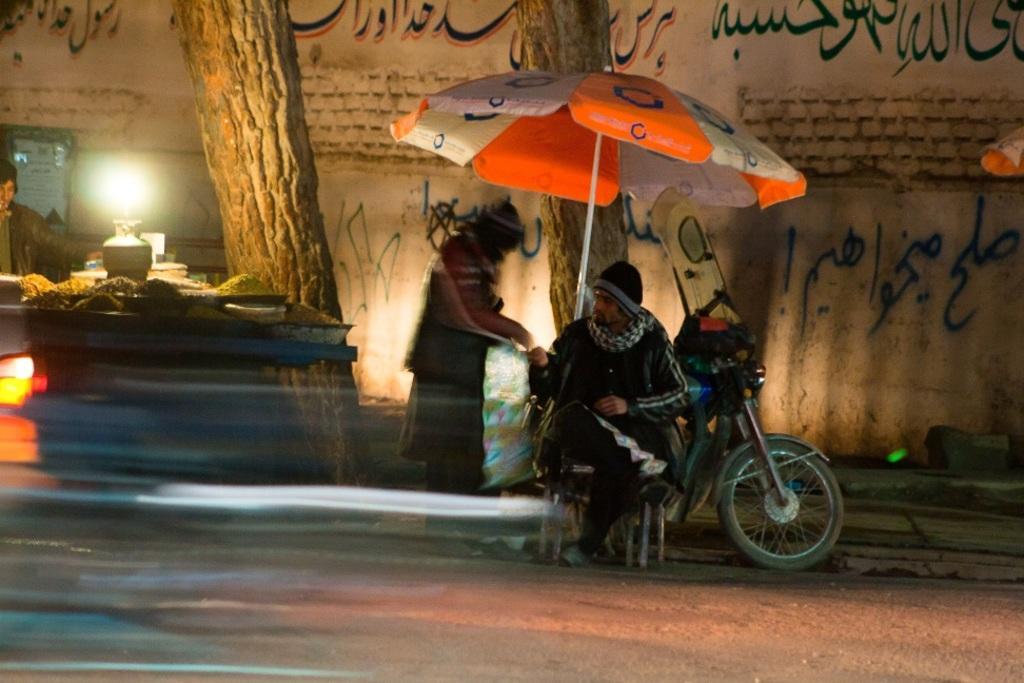In one or two sentences, can you explain what this image depicts? In this picture there is a man who is sitting on the chair in the center of the image, under an umbrella and there is another man beside him, there is a desk on the left side of the image, on which there are food items and a man, there are trees and there is Arabic language on the wall in the background area of the image. 